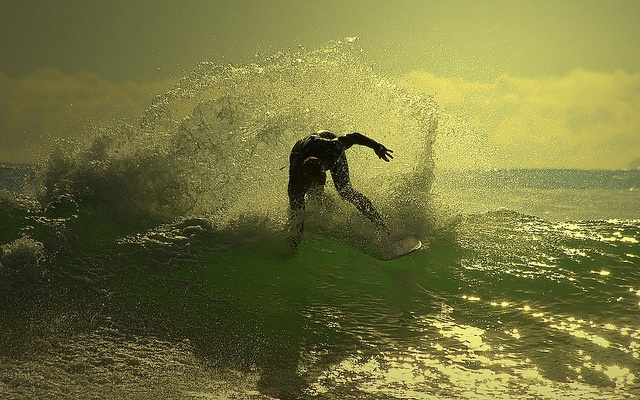Describe the objects in this image and their specific colors. I can see people in darkgreen, black, and olive tones and surfboard in darkgreen, black, and olive tones in this image. 